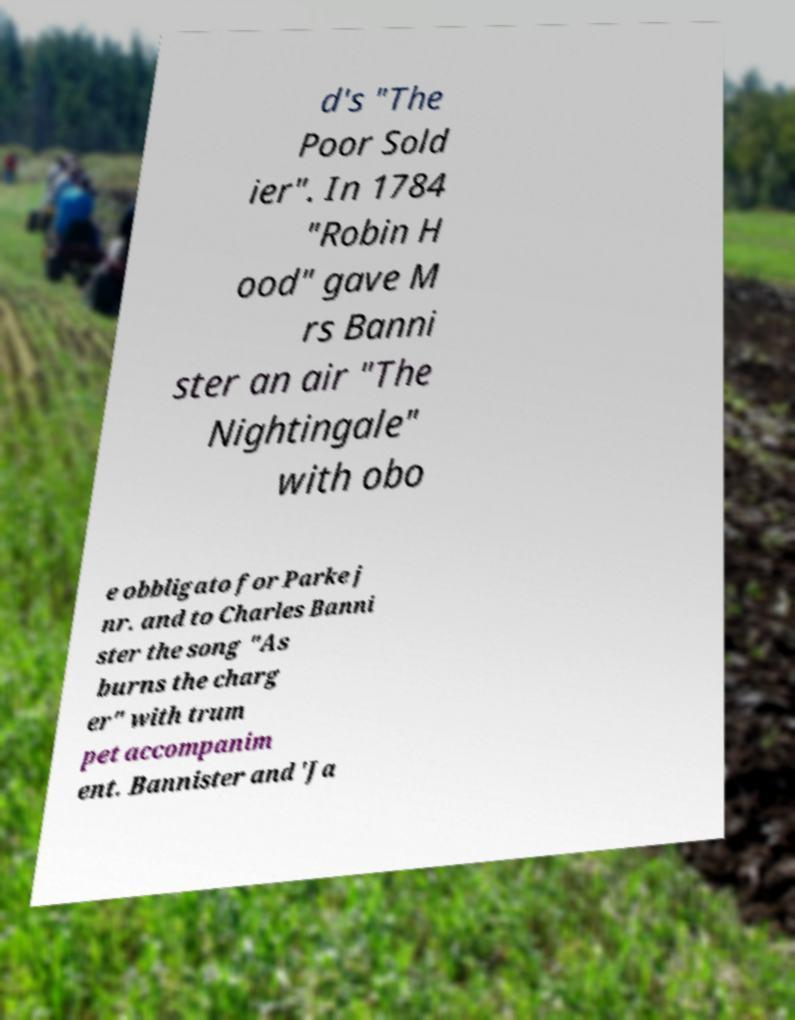Please read and relay the text visible in this image. What does it say? d's "The Poor Sold ier". In 1784 "Robin H ood" gave M rs Banni ster an air "The Nightingale" with obo e obbligato for Parke j nr. and to Charles Banni ster the song "As burns the charg er" with trum pet accompanim ent. Bannister and 'Ja 